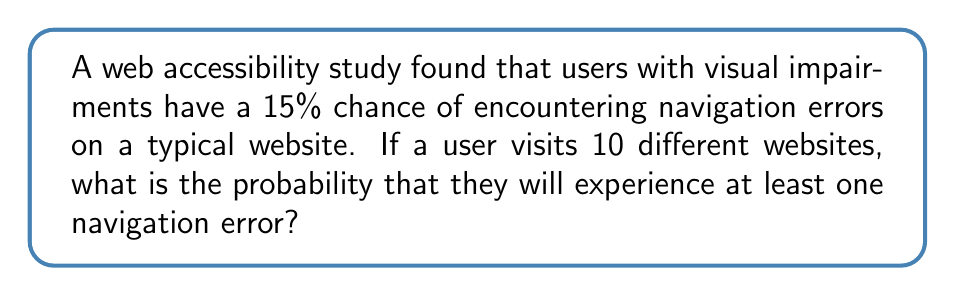Provide a solution to this math problem. To solve this problem, we can use the concept of probability and the complement rule. Let's approach this step-by-step:

1) First, let's define our events:
   - Let E be the event of experiencing at least one navigation error
   - Let N be the event of not experiencing any navigation errors

2) We're looking for P(E), but it's easier to calculate P(N) and then use the complement rule:
   
   $$P(E) = 1 - P(N)$$

3) For each website, the probability of not experiencing an error is:
   
   $$1 - 0.15 = 0.85$$

4) For the user to not experience any errors across all 10 websites, they need to not experience an error on each individual website. Since the visits are independent, we multiply these probabilities:

   $$P(N) = 0.85^{10}$$

5) We can calculate this:
   
   $$P(N) = 0.85^{10} \approx 0.1968$$

6) Now we can find P(E):

   $$P(E) = 1 - P(N) = 1 - 0.1968 \approx 0.8032$$

Therefore, the probability of experiencing at least one navigation error when visiting 10 websites is approximately 0.8032 or 80.32%.
Answer: The probability is approximately 0.8032 or 80.32%. 